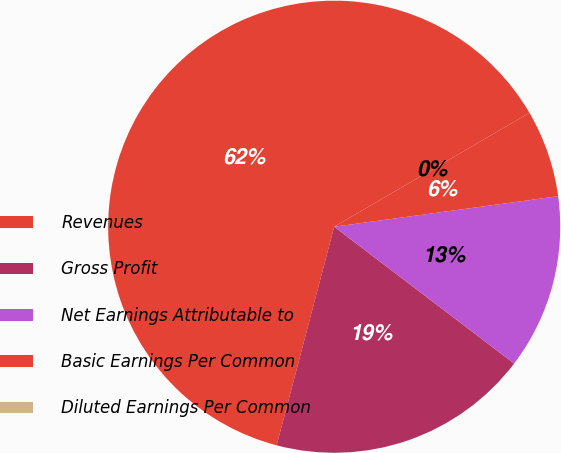Convert chart to OTSL. <chart><loc_0><loc_0><loc_500><loc_500><pie_chart><fcel>Revenues<fcel>Gross Profit<fcel>Net Earnings Attributable to<fcel>Basic Earnings Per Common<fcel>Diluted Earnings Per Common<nl><fcel>62.49%<fcel>18.75%<fcel>12.5%<fcel>6.25%<fcel>0.0%<nl></chart> 